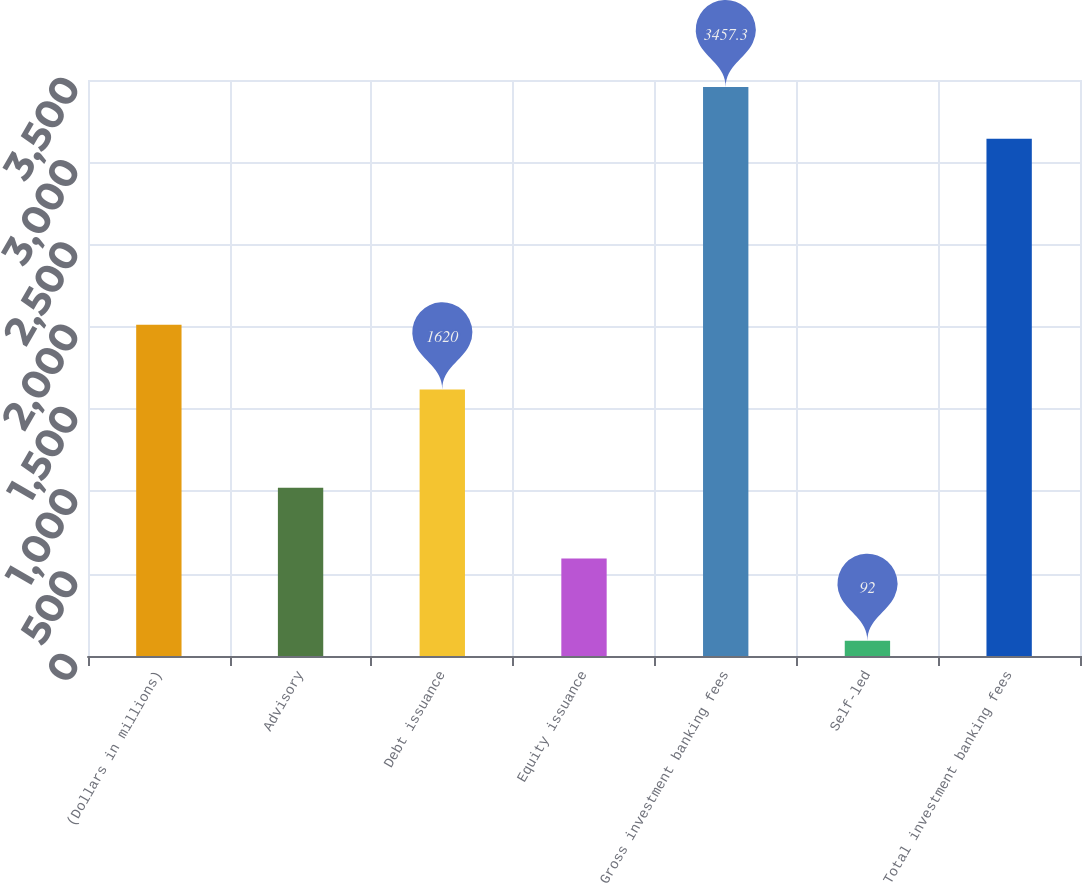Convert chart to OTSL. <chart><loc_0><loc_0><loc_500><loc_500><bar_chart><fcel>(Dollars in millions)<fcel>Advisory<fcel>Debt issuance<fcel>Equity issuance<fcel>Gross investment banking fees<fcel>Self-led<fcel>Total investment banking fees<nl><fcel>2013<fcel>1022<fcel>1620<fcel>593<fcel>3457.3<fcel>92<fcel>3143<nl></chart> 